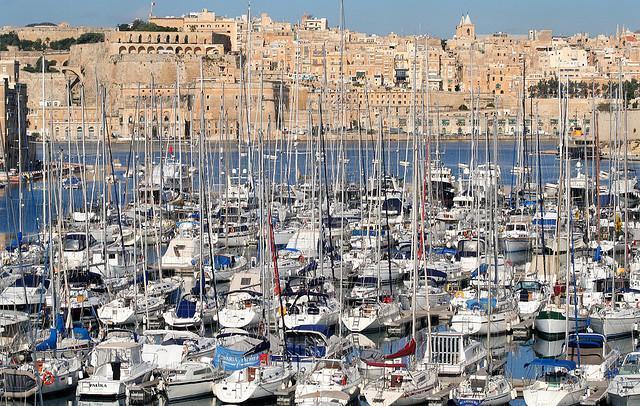What is a group of these abundant items called?
Indicate the correct response and explain using: 'Answer: answer
Rationale: rationale.'
Options: Clowder, bushel, fleet, squad. Answer: fleet.
Rationale: The group is a fleet. 